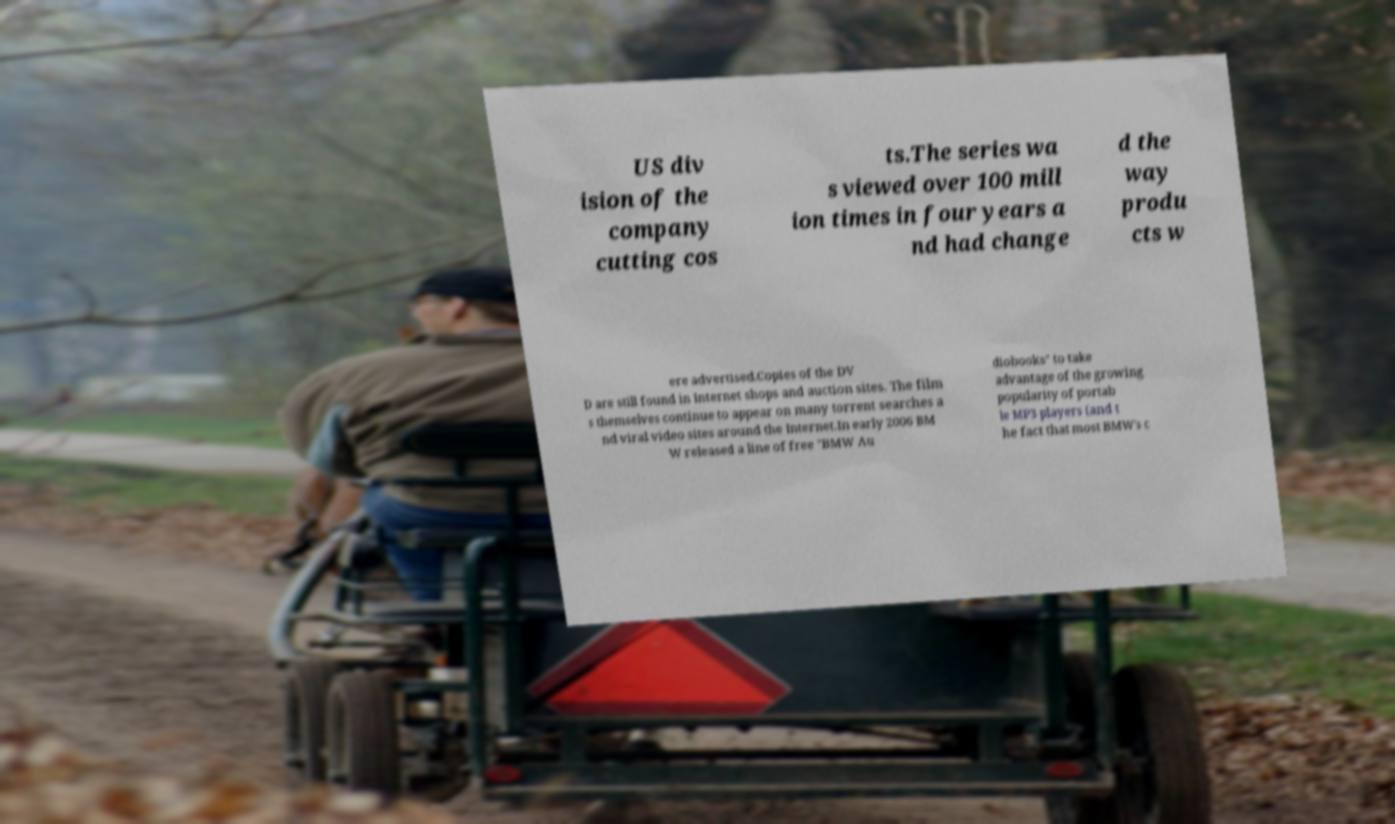What messages or text are displayed in this image? I need them in a readable, typed format. US div ision of the company cutting cos ts.The series wa s viewed over 100 mill ion times in four years a nd had change d the way produ cts w ere advertised.Copies of the DV D are still found in Internet shops and auction sites. The film s themselves continue to appear on many torrent searches a nd viral video sites around the Internet.In early 2006 BM W released a line of free "BMW Au diobooks" to take advantage of the growing popularity of portab le MP3 players (and t he fact that most BMW's c 